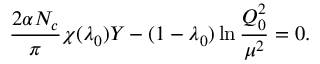<formula> <loc_0><loc_0><loc_500><loc_500>{ \frac { 2 \alpha N _ { c } } { \pi } } \chi ( \lambda _ { 0 } ) Y - ( 1 - \lambda _ { 0 } ) \ln { \frac { Q _ { 0 } ^ { 2 } } { \mu ^ { 2 } } } = 0 .</formula> 